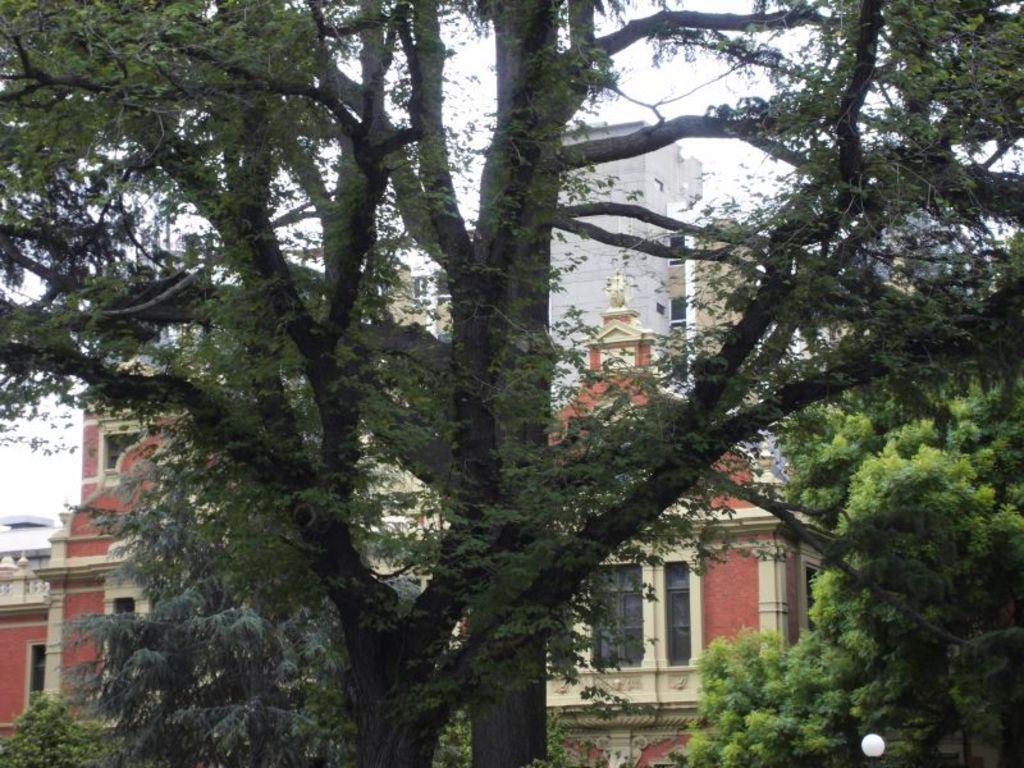In one or two sentences, can you explain what this image depicts? This image consists of buildings. In the front, we can see the trees. At the top, there is sky. 